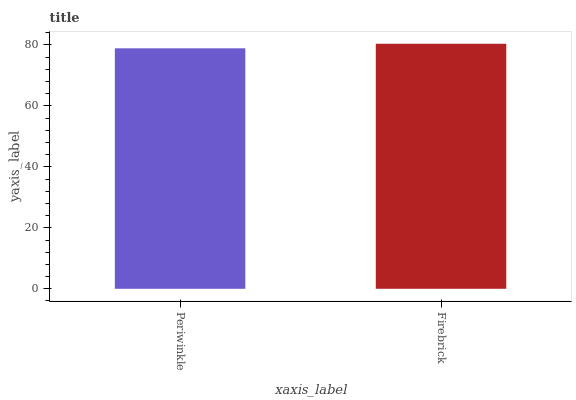Is Periwinkle the minimum?
Answer yes or no. Yes. Is Firebrick the maximum?
Answer yes or no. Yes. Is Firebrick the minimum?
Answer yes or no. No. Is Firebrick greater than Periwinkle?
Answer yes or no. Yes. Is Periwinkle less than Firebrick?
Answer yes or no. Yes. Is Periwinkle greater than Firebrick?
Answer yes or no. No. Is Firebrick less than Periwinkle?
Answer yes or no. No. Is Firebrick the high median?
Answer yes or no. Yes. Is Periwinkle the low median?
Answer yes or no. Yes. Is Periwinkle the high median?
Answer yes or no. No. Is Firebrick the low median?
Answer yes or no. No. 